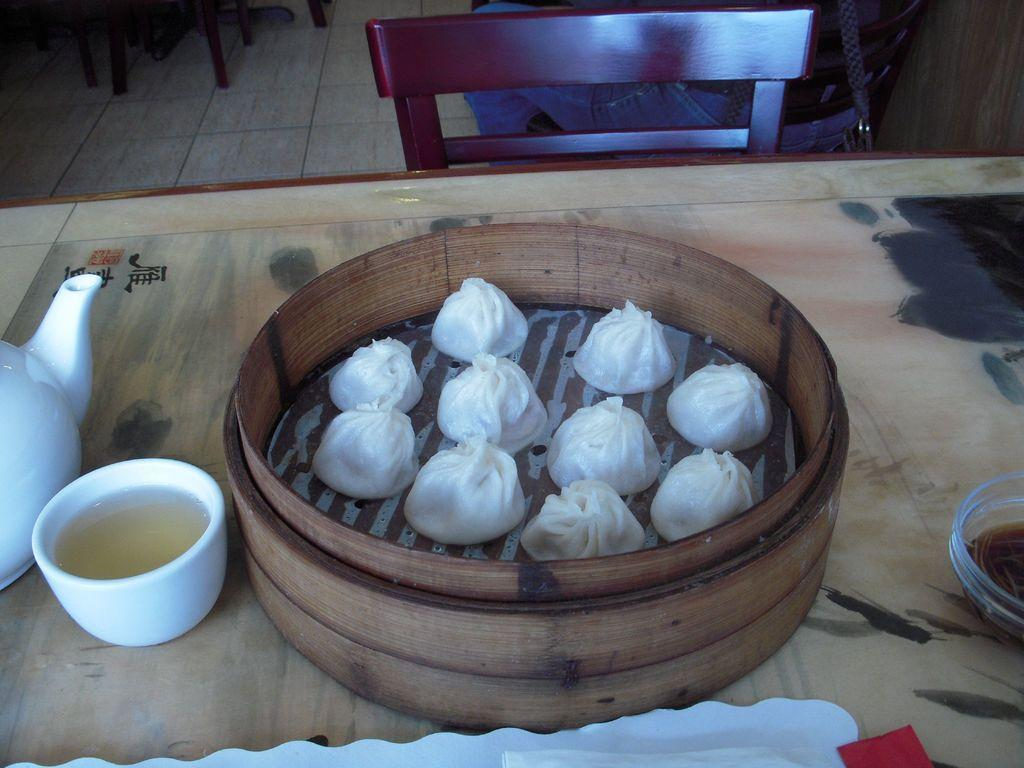What is on the table in the image? There is a kettle, a cup, food, a container, and a bowl on the table. What is the person sitting in front of the table doing? The person is sitting on a chair in front of the table. How many chairs are visible in the image? There are chairs on the floor in the image. What type of fish can be seen swimming in the event depicted in the image? There is no fish or event present in the image; it features a table with various objects and a person sitting on a chair. What type of border is visible in the image? There is no border present in the image; it focuses on the table and its contents. 